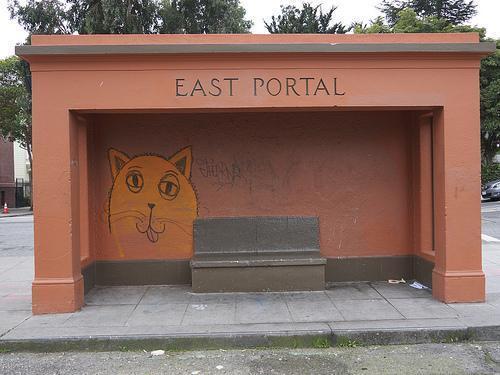How many benches are there?
Give a very brief answer. 1. 